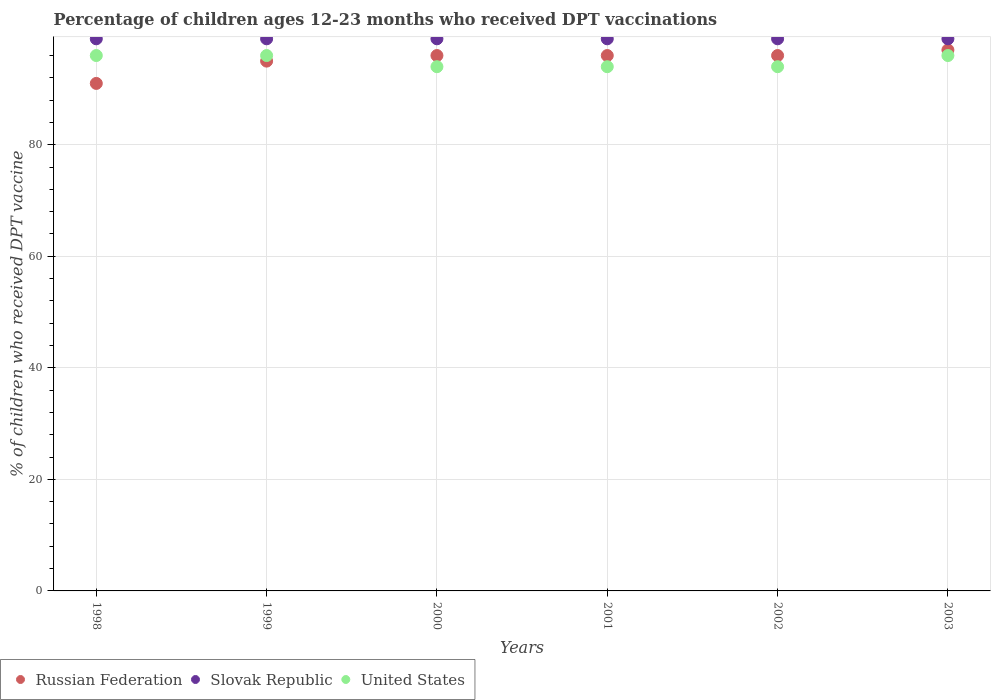How many different coloured dotlines are there?
Provide a short and direct response. 3. What is the percentage of children who received DPT vaccination in Russian Federation in 1998?
Keep it short and to the point. 91. Across all years, what is the maximum percentage of children who received DPT vaccination in United States?
Give a very brief answer. 96. Across all years, what is the minimum percentage of children who received DPT vaccination in Slovak Republic?
Ensure brevity in your answer.  99. In which year was the percentage of children who received DPT vaccination in Russian Federation maximum?
Your answer should be very brief. 2003. What is the total percentage of children who received DPT vaccination in Russian Federation in the graph?
Your response must be concise. 571. What is the difference between the percentage of children who received DPT vaccination in United States in 1999 and that in 2000?
Give a very brief answer. 2. What is the difference between the percentage of children who received DPT vaccination in Slovak Republic in 2002 and the percentage of children who received DPT vaccination in United States in 1999?
Keep it short and to the point. 3. What is the average percentage of children who received DPT vaccination in Russian Federation per year?
Your answer should be compact. 95.17. In the year 1998, what is the difference between the percentage of children who received DPT vaccination in United States and percentage of children who received DPT vaccination in Slovak Republic?
Give a very brief answer. -3. In how many years, is the percentage of children who received DPT vaccination in Russian Federation greater than 88 %?
Your answer should be very brief. 6. What is the ratio of the percentage of children who received DPT vaccination in United States in 2001 to that in 2002?
Make the answer very short. 1. Is the difference between the percentage of children who received DPT vaccination in United States in 2002 and 2003 greater than the difference between the percentage of children who received DPT vaccination in Slovak Republic in 2002 and 2003?
Provide a succinct answer. No. What is the difference between the highest and the lowest percentage of children who received DPT vaccination in Slovak Republic?
Make the answer very short. 0. Is it the case that in every year, the sum of the percentage of children who received DPT vaccination in Russian Federation and percentage of children who received DPT vaccination in Slovak Republic  is greater than the percentage of children who received DPT vaccination in United States?
Your response must be concise. Yes. Does the percentage of children who received DPT vaccination in Russian Federation monotonically increase over the years?
Make the answer very short. No. Is the percentage of children who received DPT vaccination in United States strictly greater than the percentage of children who received DPT vaccination in Russian Federation over the years?
Provide a short and direct response. No. Is the percentage of children who received DPT vaccination in Slovak Republic strictly less than the percentage of children who received DPT vaccination in United States over the years?
Provide a short and direct response. No. Are the values on the major ticks of Y-axis written in scientific E-notation?
Your answer should be compact. No. Does the graph contain any zero values?
Your answer should be very brief. No. Does the graph contain grids?
Your answer should be very brief. Yes. Where does the legend appear in the graph?
Your answer should be very brief. Bottom left. How many legend labels are there?
Give a very brief answer. 3. How are the legend labels stacked?
Your answer should be very brief. Horizontal. What is the title of the graph?
Your answer should be compact. Percentage of children ages 12-23 months who received DPT vaccinations. Does "New Zealand" appear as one of the legend labels in the graph?
Ensure brevity in your answer.  No. What is the label or title of the X-axis?
Your response must be concise. Years. What is the label or title of the Y-axis?
Your response must be concise. % of children who received DPT vaccine. What is the % of children who received DPT vaccine in Russian Federation in 1998?
Offer a terse response. 91. What is the % of children who received DPT vaccine in Slovak Republic in 1998?
Ensure brevity in your answer.  99. What is the % of children who received DPT vaccine in United States in 1998?
Your answer should be compact. 96. What is the % of children who received DPT vaccine in Russian Federation in 1999?
Offer a very short reply. 95. What is the % of children who received DPT vaccine of United States in 1999?
Your answer should be very brief. 96. What is the % of children who received DPT vaccine of Russian Federation in 2000?
Your answer should be very brief. 96. What is the % of children who received DPT vaccine of Slovak Republic in 2000?
Your response must be concise. 99. What is the % of children who received DPT vaccine of United States in 2000?
Offer a very short reply. 94. What is the % of children who received DPT vaccine of Russian Federation in 2001?
Provide a short and direct response. 96. What is the % of children who received DPT vaccine in Slovak Republic in 2001?
Keep it short and to the point. 99. What is the % of children who received DPT vaccine of United States in 2001?
Your response must be concise. 94. What is the % of children who received DPT vaccine of Russian Federation in 2002?
Offer a terse response. 96. What is the % of children who received DPT vaccine in United States in 2002?
Offer a very short reply. 94. What is the % of children who received DPT vaccine of Russian Federation in 2003?
Keep it short and to the point. 97. What is the % of children who received DPT vaccine of United States in 2003?
Provide a short and direct response. 96. Across all years, what is the maximum % of children who received DPT vaccine of Russian Federation?
Keep it short and to the point. 97. Across all years, what is the maximum % of children who received DPT vaccine of Slovak Republic?
Make the answer very short. 99. Across all years, what is the maximum % of children who received DPT vaccine in United States?
Provide a succinct answer. 96. Across all years, what is the minimum % of children who received DPT vaccine of Russian Federation?
Provide a short and direct response. 91. Across all years, what is the minimum % of children who received DPT vaccine of United States?
Make the answer very short. 94. What is the total % of children who received DPT vaccine of Russian Federation in the graph?
Keep it short and to the point. 571. What is the total % of children who received DPT vaccine of Slovak Republic in the graph?
Provide a succinct answer. 594. What is the total % of children who received DPT vaccine in United States in the graph?
Your answer should be compact. 570. What is the difference between the % of children who received DPT vaccine of Slovak Republic in 1998 and that in 1999?
Offer a very short reply. 0. What is the difference between the % of children who received DPT vaccine of Russian Federation in 1998 and that in 2000?
Give a very brief answer. -5. What is the difference between the % of children who received DPT vaccine of Slovak Republic in 1998 and that in 2000?
Your response must be concise. 0. What is the difference between the % of children who received DPT vaccine of United States in 1998 and that in 2000?
Make the answer very short. 2. What is the difference between the % of children who received DPT vaccine in Slovak Republic in 1998 and that in 2001?
Offer a very short reply. 0. What is the difference between the % of children who received DPT vaccine of Russian Federation in 1998 and that in 2002?
Keep it short and to the point. -5. What is the difference between the % of children who received DPT vaccine in Slovak Republic in 1998 and that in 2003?
Give a very brief answer. 0. What is the difference between the % of children who received DPT vaccine in Slovak Republic in 1999 and that in 2000?
Offer a terse response. 0. What is the difference between the % of children who received DPT vaccine of Russian Federation in 1999 and that in 2002?
Offer a very short reply. -1. What is the difference between the % of children who received DPT vaccine in Slovak Republic in 1999 and that in 2002?
Provide a short and direct response. 0. What is the difference between the % of children who received DPT vaccine of Slovak Republic in 1999 and that in 2003?
Give a very brief answer. 0. What is the difference between the % of children who received DPT vaccine in United States in 1999 and that in 2003?
Offer a very short reply. 0. What is the difference between the % of children who received DPT vaccine in Russian Federation in 2000 and that in 2001?
Provide a short and direct response. 0. What is the difference between the % of children who received DPT vaccine in Russian Federation in 2000 and that in 2002?
Your answer should be compact. 0. What is the difference between the % of children who received DPT vaccine in Russian Federation in 2000 and that in 2003?
Your response must be concise. -1. What is the difference between the % of children who received DPT vaccine of Slovak Republic in 2000 and that in 2003?
Give a very brief answer. 0. What is the difference between the % of children who received DPT vaccine in United States in 2001 and that in 2002?
Provide a succinct answer. 0. What is the difference between the % of children who received DPT vaccine of Russian Federation in 2001 and that in 2003?
Your answer should be compact. -1. What is the difference between the % of children who received DPT vaccine of United States in 2001 and that in 2003?
Provide a short and direct response. -2. What is the difference between the % of children who received DPT vaccine in Russian Federation in 2002 and that in 2003?
Provide a succinct answer. -1. What is the difference between the % of children who received DPT vaccine of Russian Federation in 1998 and the % of children who received DPT vaccine of Slovak Republic in 1999?
Offer a very short reply. -8. What is the difference between the % of children who received DPT vaccine in Russian Federation in 1998 and the % of children who received DPT vaccine in United States in 1999?
Give a very brief answer. -5. What is the difference between the % of children who received DPT vaccine of Russian Federation in 1998 and the % of children who received DPT vaccine of Slovak Republic in 2000?
Offer a terse response. -8. What is the difference between the % of children who received DPT vaccine in Russian Federation in 1998 and the % of children who received DPT vaccine in Slovak Republic in 2001?
Ensure brevity in your answer.  -8. What is the difference between the % of children who received DPT vaccine of Russian Federation in 1998 and the % of children who received DPT vaccine of United States in 2001?
Offer a terse response. -3. What is the difference between the % of children who received DPT vaccine in Slovak Republic in 1998 and the % of children who received DPT vaccine in United States in 2001?
Provide a succinct answer. 5. What is the difference between the % of children who received DPT vaccine in Russian Federation in 1998 and the % of children who received DPT vaccine in Slovak Republic in 2003?
Keep it short and to the point. -8. What is the difference between the % of children who received DPT vaccine of Russian Federation in 1998 and the % of children who received DPT vaccine of United States in 2003?
Make the answer very short. -5. What is the difference between the % of children who received DPT vaccine of Russian Federation in 1999 and the % of children who received DPT vaccine of United States in 2000?
Offer a terse response. 1. What is the difference between the % of children who received DPT vaccine of Russian Federation in 1999 and the % of children who received DPT vaccine of Slovak Republic in 2001?
Your response must be concise. -4. What is the difference between the % of children who received DPT vaccine in Slovak Republic in 1999 and the % of children who received DPT vaccine in United States in 2001?
Ensure brevity in your answer.  5. What is the difference between the % of children who received DPT vaccine in Russian Federation in 1999 and the % of children who received DPT vaccine in United States in 2002?
Your answer should be compact. 1. What is the difference between the % of children who received DPT vaccine in Slovak Republic in 1999 and the % of children who received DPT vaccine in United States in 2002?
Provide a succinct answer. 5. What is the difference between the % of children who received DPT vaccine in Russian Federation in 1999 and the % of children who received DPT vaccine in Slovak Republic in 2003?
Ensure brevity in your answer.  -4. What is the difference between the % of children who received DPT vaccine in Russian Federation in 1999 and the % of children who received DPT vaccine in United States in 2003?
Ensure brevity in your answer.  -1. What is the difference between the % of children who received DPT vaccine in Russian Federation in 2000 and the % of children who received DPT vaccine in United States in 2001?
Your answer should be compact. 2. What is the difference between the % of children who received DPT vaccine of Russian Federation in 2000 and the % of children who received DPT vaccine of Slovak Republic in 2002?
Keep it short and to the point. -3. What is the difference between the % of children who received DPT vaccine of Slovak Republic in 2000 and the % of children who received DPT vaccine of United States in 2002?
Your answer should be very brief. 5. What is the difference between the % of children who received DPT vaccine of Russian Federation in 2000 and the % of children who received DPT vaccine of United States in 2003?
Keep it short and to the point. 0. What is the difference between the % of children who received DPT vaccine in Russian Federation in 2001 and the % of children who received DPT vaccine in United States in 2002?
Offer a very short reply. 2. What is the difference between the % of children who received DPT vaccine in Slovak Republic in 2001 and the % of children who received DPT vaccine in United States in 2002?
Ensure brevity in your answer.  5. What is the difference between the % of children who received DPT vaccine in Russian Federation in 2001 and the % of children who received DPT vaccine in Slovak Republic in 2003?
Your answer should be compact. -3. What is the difference between the % of children who received DPT vaccine of Russian Federation in 2001 and the % of children who received DPT vaccine of United States in 2003?
Your answer should be very brief. 0. What is the difference between the % of children who received DPT vaccine of Slovak Republic in 2001 and the % of children who received DPT vaccine of United States in 2003?
Ensure brevity in your answer.  3. What is the difference between the % of children who received DPT vaccine in Russian Federation in 2002 and the % of children who received DPT vaccine in Slovak Republic in 2003?
Offer a terse response. -3. What is the average % of children who received DPT vaccine of Russian Federation per year?
Your response must be concise. 95.17. What is the average % of children who received DPT vaccine in United States per year?
Provide a short and direct response. 95. In the year 1998, what is the difference between the % of children who received DPT vaccine in Russian Federation and % of children who received DPT vaccine in Slovak Republic?
Your answer should be compact. -8. In the year 1998, what is the difference between the % of children who received DPT vaccine of Russian Federation and % of children who received DPT vaccine of United States?
Offer a terse response. -5. In the year 1998, what is the difference between the % of children who received DPT vaccine in Slovak Republic and % of children who received DPT vaccine in United States?
Keep it short and to the point. 3. In the year 1999, what is the difference between the % of children who received DPT vaccine in Russian Federation and % of children who received DPT vaccine in Slovak Republic?
Your answer should be compact. -4. In the year 2000, what is the difference between the % of children who received DPT vaccine in Russian Federation and % of children who received DPT vaccine in Slovak Republic?
Offer a very short reply. -3. In the year 2000, what is the difference between the % of children who received DPT vaccine of Russian Federation and % of children who received DPT vaccine of United States?
Your response must be concise. 2. In the year 2000, what is the difference between the % of children who received DPT vaccine of Slovak Republic and % of children who received DPT vaccine of United States?
Provide a short and direct response. 5. In the year 2001, what is the difference between the % of children who received DPT vaccine of Slovak Republic and % of children who received DPT vaccine of United States?
Offer a very short reply. 5. In the year 2002, what is the difference between the % of children who received DPT vaccine in Russian Federation and % of children who received DPT vaccine in United States?
Provide a succinct answer. 2. In the year 2003, what is the difference between the % of children who received DPT vaccine of Slovak Republic and % of children who received DPT vaccine of United States?
Provide a succinct answer. 3. What is the ratio of the % of children who received DPT vaccine of Russian Federation in 1998 to that in 1999?
Provide a short and direct response. 0.96. What is the ratio of the % of children who received DPT vaccine of United States in 1998 to that in 1999?
Keep it short and to the point. 1. What is the ratio of the % of children who received DPT vaccine in Russian Federation in 1998 to that in 2000?
Your answer should be compact. 0.95. What is the ratio of the % of children who received DPT vaccine of United States in 1998 to that in 2000?
Your answer should be very brief. 1.02. What is the ratio of the % of children who received DPT vaccine in Russian Federation in 1998 to that in 2001?
Make the answer very short. 0.95. What is the ratio of the % of children who received DPT vaccine of Slovak Republic in 1998 to that in 2001?
Give a very brief answer. 1. What is the ratio of the % of children who received DPT vaccine in United States in 1998 to that in 2001?
Your answer should be compact. 1.02. What is the ratio of the % of children who received DPT vaccine in Russian Federation in 1998 to that in 2002?
Provide a succinct answer. 0.95. What is the ratio of the % of children who received DPT vaccine of Slovak Republic in 1998 to that in 2002?
Ensure brevity in your answer.  1. What is the ratio of the % of children who received DPT vaccine of United States in 1998 to that in 2002?
Give a very brief answer. 1.02. What is the ratio of the % of children who received DPT vaccine of Russian Federation in 1998 to that in 2003?
Your answer should be very brief. 0.94. What is the ratio of the % of children who received DPT vaccine of Slovak Republic in 1998 to that in 2003?
Offer a terse response. 1. What is the ratio of the % of children who received DPT vaccine in United States in 1998 to that in 2003?
Give a very brief answer. 1. What is the ratio of the % of children who received DPT vaccine in United States in 1999 to that in 2000?
Your answer should be compact. 1.02. What is the ratio of the % of children who received DPT vaccine of Russian Federation in 1999 to that in 2001?
Give a very brief answer. 0.99. What is the ratio of the % of children who received DPT vaccine in Slovak Republic in 1999 to that in 2001?
Give a very brief answer. 1. What is the ratio of the % of children who received DPT vaccine of United States in 1999 to that in 2001?
Your response must be concise. 1.02. What is the ratio of the % of children who received DPT vaccine of Slovak Republic in 1999 to that in 2002?
Ensure brevity in your answer.  1. What is the ratio of the % of children who received DPT vaccine in United States in 1999 to that in 2002?
Offer a very short reply. 1.02. What is the ratio of the % of children who received DPT vaccine of Russian Federation in 1999 to that in 2003?
Keep it short and to the point. 0.98. What is the ratio of the % of children who received DPT vaccine of Slovak Republic in 2000 to that in 2001?
Your answer should be compact. 1. What is the ratio of the % of children who received DPT vaccine in United States in 2000 to that in 2001?
Your answer should be very brief. 1. What is the ratio of the % of children who received DPT vaccine in Russian Federation in 2000 to that in 2002?
Provide a succinct answer. 1. What is the ratio of the % of children who received DPT vaccine in Slovak Republic in 2000 to that in 2002?
Make the answer very short. 1. What is the ratio of the % of children who received DPT vaccine in United States in 2000 to that in 2003?
Your answer should be compact. 0.98. What is the ratio of the % of children who received DPT vaccine of Slovak Republic in 2001 to that in 2002?
Give a very brief answer. 1. What is the ratio of the % of children who received DPT vaccine in Russian Federation in 2001 to that in 2003?
Make the answer very short. 0.99. What is the ratio of the % of children who received DPT vaccine in United States in 2001 to that in 2003?
Your answer should be very brief. 0.98. What is the ratio of the % of children who received DPT vaccine in Slovak Republic in 2002 to that in 2003?
Give a very brief answer. 1. What is the ratio of the % of children who received DPT vaccine in United States in 2002 to that in 2003?
Your answer should be compact. 0.98. What is the difference between the highest and the second highest % of children who received DPT vaccine of United States?
Your response must be concise. 0. What is the difference between the highest and the lowest % of children who received DPT vaccine of Russian Federation?
Offer a very short reply. 6. 